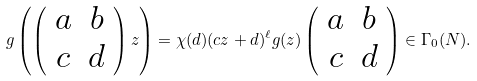<formula> <loc_0><loc_0><loc_500><loc_500>g \left ( \left ( \begin{array} { c c } a & b \\ c & d \end{array} \right ) z \right ) = \chi ( d ) ( c z + d ) ^ { \ell } g ( z ) \left ( \begin{array} { c c } a & b \\ c & d \end{array} \right ) \in \Gamma _ { 0 } ( N ) .</formula> 